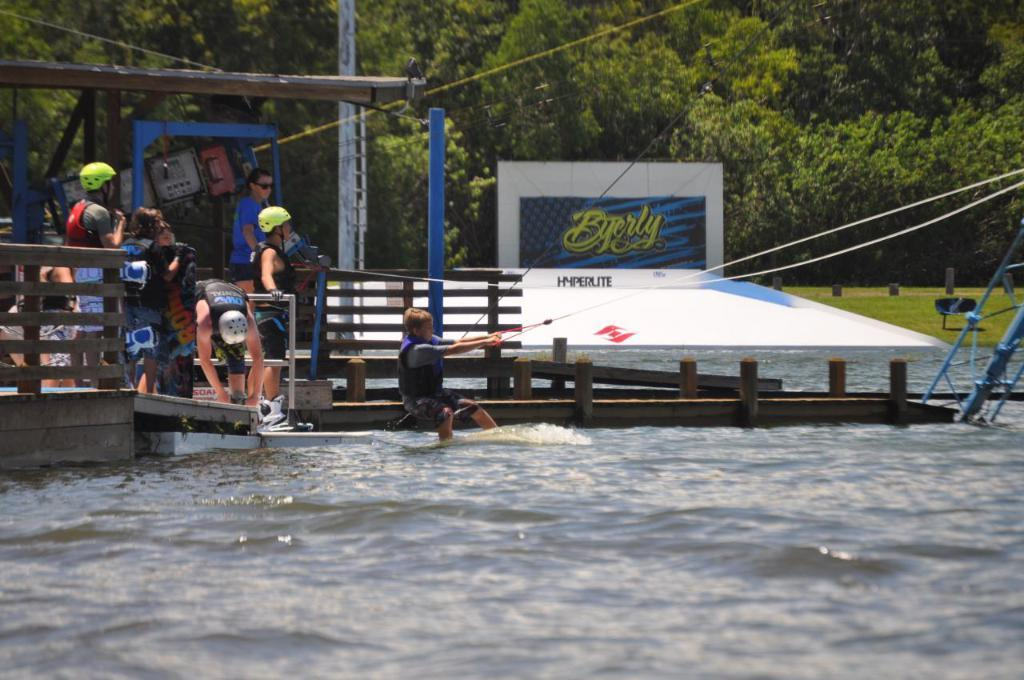<image>
Provide a brief description of the given image. A scene at a water dock with a sign behind it that says Byerly. 